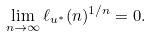Convert formula to latex. <formula><loc_0><loc_0><loc_500><loc_500>\lim _ { n \to \infty } \ell _ { u ^ { * } } ( n ) ^ { 1 / n } = 0 .</formula> 